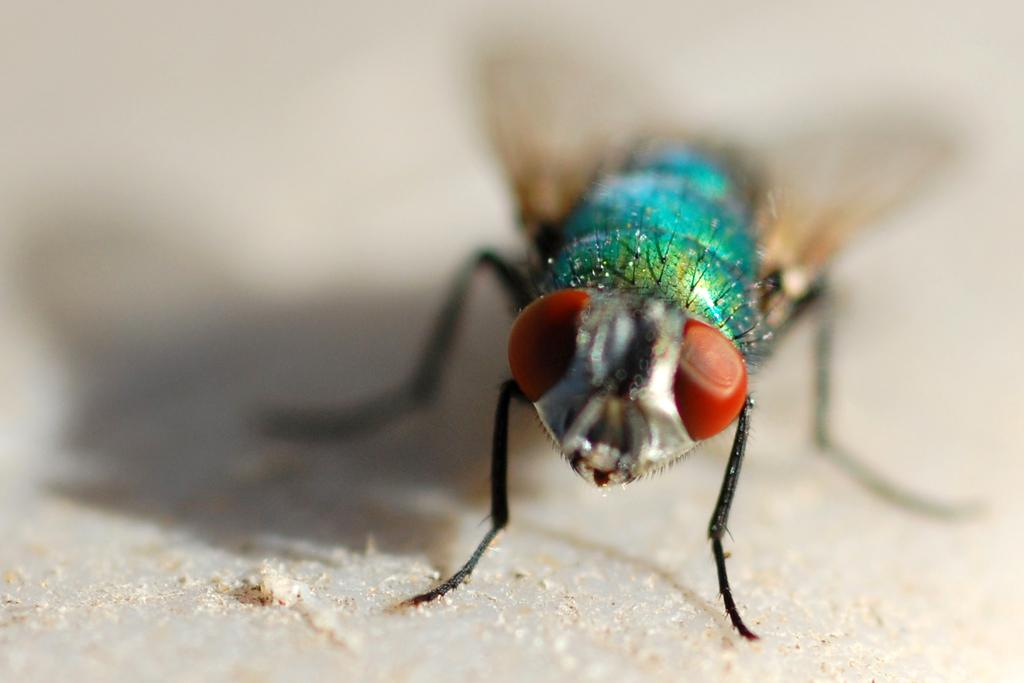What type of creature can be seen in the image? There is an insect in the image. What type of suit is the bear wearing in the image? There is no bear or suit present in the image; it features an insect. 